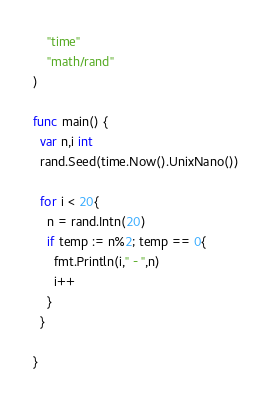Convert code to text. <code><loc_0><loc_0><loc_500><loc_500><_Go_>    "time"
    "math/rand"
)

func main() {
  var n,i int
  rand.Seed(time.Now().UnixNano())
  
  for i < 20{
    n = rand.Intn(20)
    if temp := n%2; temp == 0{
      fmt.Println(i," - ",n)
      i++
    }
  }

}
</code> 